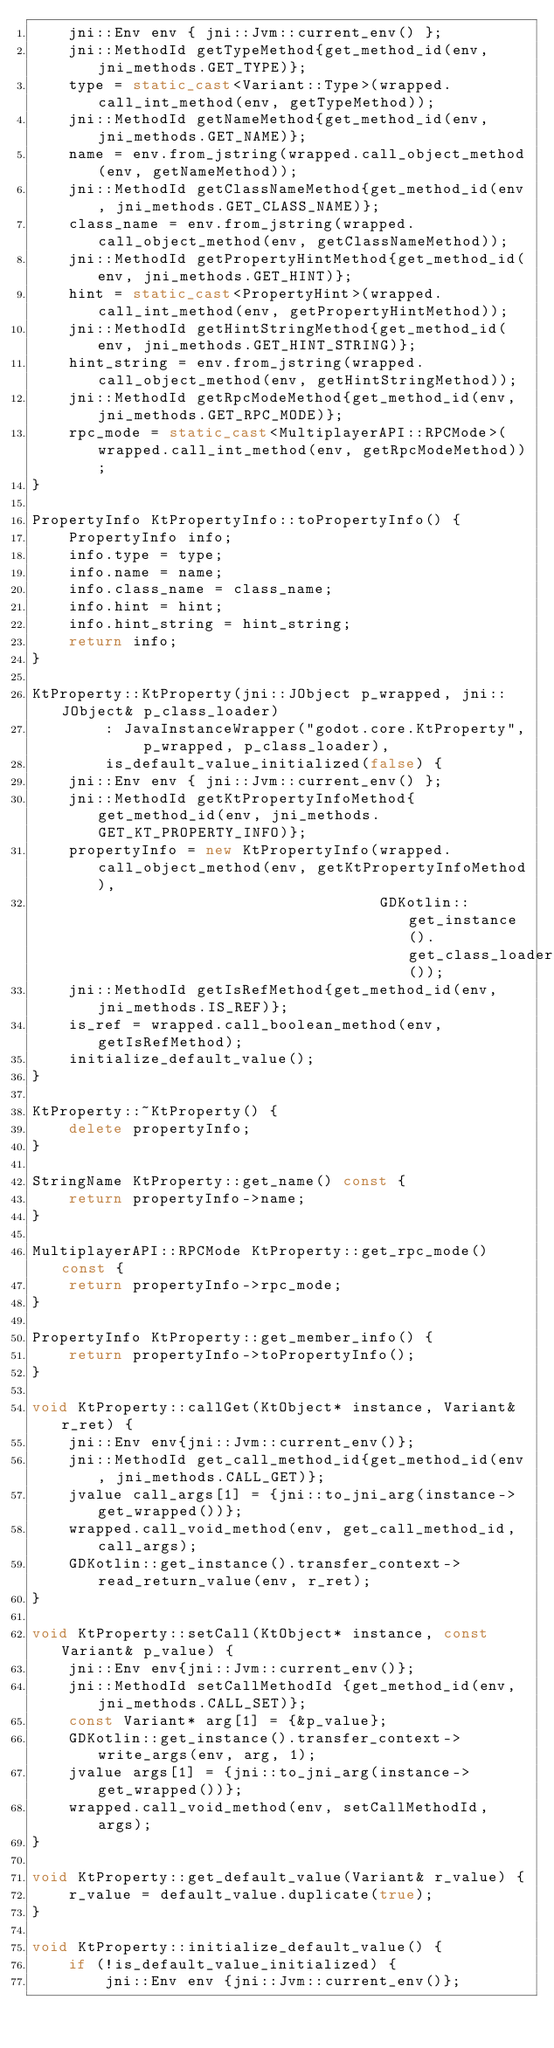<code> <loc_0><loc_0><loc_500><loc_500><_C++_>    jni::Env env { jni::Jvm::current_env() };
    jni::MethodId getTypeMethod{get_method_id(env, jni_methods.GET_TYPE)};
    type = static_cast<Variant::Type>(wrapped.call_int_method(env, getTypeMethod));
    jni::MethodId getNameMethod{get_method_id(env, jni_methods.GET_NAME)};
    name = env.from_jstring(wrapped.call_object_method(env, getNameMethod));
    jni::MethodId getClassNameMethod{get_method_id(env, jni_methods.GET_CLASS_NAME)};
    class_name = env.from_jstring(wrapped.call_object_method(env, getClassNameMethod));
    jni::MethodId getPropertyHintMethod{get_method_id(env, jni_methods.GET_HINT)};
    hint = static_cast<PropertyHint>(wrapped.call_int_method(env, getPropertyHintMethod));
    jni::MethodId getHintStringMethod{get_method_id(env, jni_methods.GET_HINT_STRING)};
    hint_string = env.from_jstring(wrapped.call_object_method(env, getHintStringMethod));
    jni::MethodId getRpcModeMethod{get_method_id(env, jni_methods.GET_RPC_MODE)};
    rpc_mode = static_cast<MultiplayerAPI::RPCMode>(wrapped.call_int_method(env, getRpcModeMethod));
}

PropertyInfo KtPropertyInfo::toPropertyInfo() {
    PropertyInfo info;
    info.type = type;
    info.name = name;
    info.class_name = class_name;
    info.hint = hint;
    info.hint_string = hint_string;
    return info;
}

KtProperty::KtProperty(jni::JObject p_wrapped, jni::JObject& p_class_loader)
        : JavaInstanceWrapper("godot.core.KtProperty", p_wrapped, p_class_loader),
        is_default_value_initialized(false) {
    jni::Env env { jni::Jvm::current_env() };
    jni::MethodId getKtPropertyInfoMethod{get_method_id(env, jni_methods.GET_KT_PROPERTY_INFO)};
    propertyInfo = new KtPropertyInfo(wrapped.call_object_method(env, getKtPropertyInfoMethod),
                                      GDKotlin::get_instance().get_class_loader());
    jni::MethodId getIsRefMethod{get_method_id(env, jni_methods.IS_REF)};
    is_ref = wrapped.call_boolean_method(env, getIsRefMethod);
    initialize_default_value();
}

KtProperty::~KtProperty() {
    delete propertyInfo;
}

StringName KtProperty::get_name() const {
    return propertyInfo->name;
}

MultiplayerAPI::RPCMode KtProperty::get_rpc_mode() const {
    return propertyInfo->rpc_mode;
}

PropertyInfo KtProperty::get_member_info() {
    return propertyInfo->toPropertyInfo();
}

void KtProperty::callGet(KtObject* instance, Variant& r_ret) {
    jni::Env env{jni::Jvm::current_env()};
    jni::MethodId get_call_method_id{get_method_id(env, jni_methods.CALL_GET)};
    jvalue call_args[1] = {jni::to_jni_arg(instance->get_wrapped())};
    wrapped.call_void_method(env, get_call_method_id, call_args);
    GDKotlin::get_instance().transfer_context->read_return_value(env, r_ret);
}

void KtProperty::setCall(KtObject* instance, const Variant& p_value) {
    jni::Env env{jni::Jvm::current_env()};
    jni::MethodId setCallMethodId {get_method_id(env, jni_methods.CALL_SET)};
    const Variant* arg[1] = {&p_value};
    GDKotlin::get_instance().transfer_context->write_args(env, arg, 1);
    jvalue args[1] = {jni::to_jni_arg(instance->get_wrapped())};
    wrapped.call_void_method(env, setCallMethodId, args);
}

void KtProperty::get_default_value(Variant& r_value) {
    r_value = default_value.duplicate(true);
}

void KtProperty::initialize_default_value() {
    if (!is_default_value_initialized) {
        jni::Env env {jni::Jvm::current_env()};</code> 